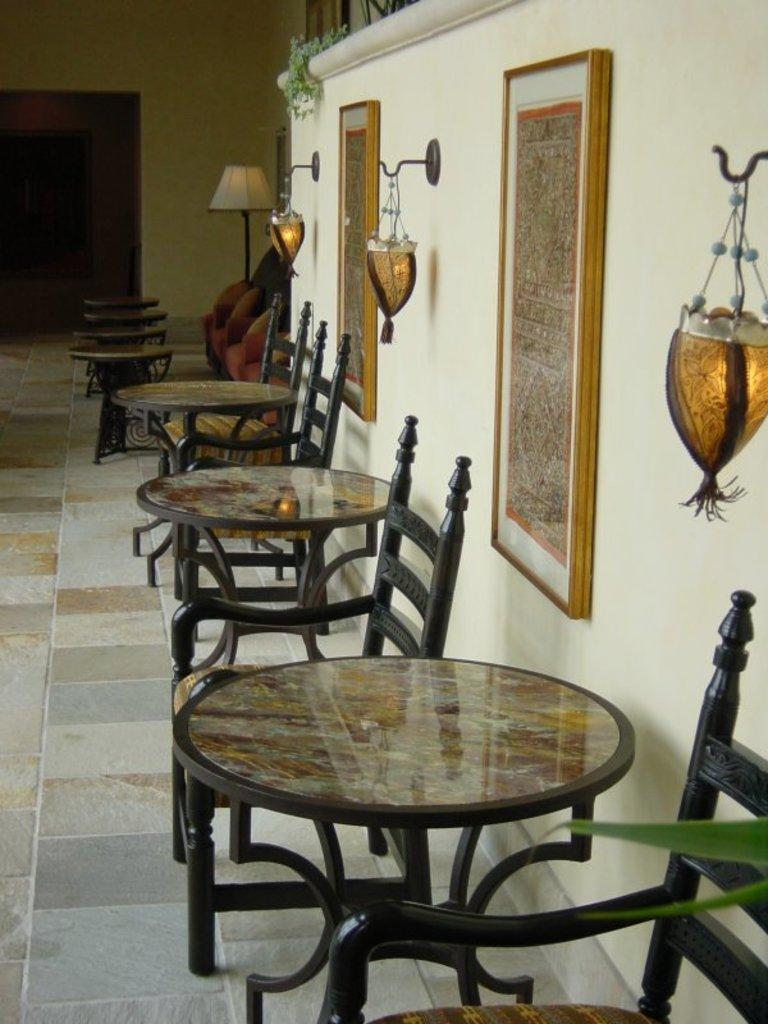What is located in the middle of the image? There are tables arranged in the middle of the image. What can be seen on the right side of the image? There is a wall on the right side of the image. What is attached to the wall? There are two frames attached to the wall. What type of bait is hanging from the frames on the wall? There is no bait present in the image; the frames are attached to the wall with no bait visible. Can you tell me the time displayed on the clock in the image? There is no clock present in the image, so the time cannot be determined. 